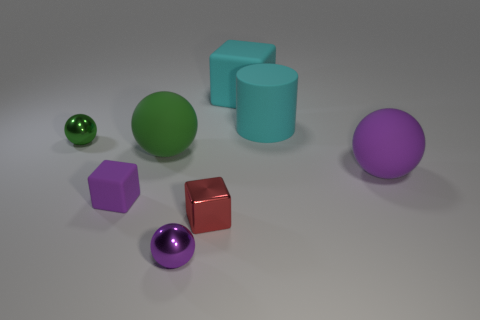There is a rubber block that is in front of the tiny green metallic sphere; what number of green things are right of it?
Provide a short and direct response. 1. There is a large matte thing that is left of the red metallic object; does it have the same color as the tiny rubber cube?
Offer a terse response. No. How many things are either big gray rubber balls or purple spheres left of the small shiny block?
Your answer should be compact. 1. Does the green object that is to the left of the large green matte ball have the same shape as the small red metallic object behind the tiny purple metallic ball?
Provide a succinct answer. No. Is there any other thing that is the same color as the tiny shiny block?
Ensure brevity in your answer.  No. What shape is the tiny purple object that is made of the same material as the large green ball?
Ensure brevity in your answer.  Cube. There is a object that is to the left of the metallic block and in front of the tiny matte block; what is its material?
Make the answer very short. Metal. Are there any other things that have the same size as the cyan cylinder?
Provide a short and direct response. Yes. Is the rubber cylinder the same color as the tiny matte object?
Make the answer very short. No. There is a big object that is the same color as the large cube; what shape is it?
Ensure brevity in your answer.  Cylinder. 